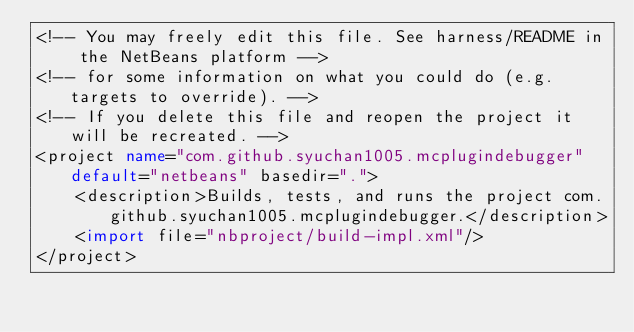Convert code to text. <code><loc_0><loc_0><loc_500><loc_500><_XML_><!-- You may freely edit this file. See harness/README in the NetBeans platform -->
<!-- for some information on what you could do (e.g. targets to override). -->
<!-- If you delete this file and reopen the project it will be recreated. -->
<project name="com.github.syuchan1005.mcplugindebugger" default="netbeans" basedir=".">
    <description>Builds, tests, and runs the project com.github.syuchan1005.mcplugindebugger.</description>
    <import file="nbproject/build-impl.xml"/>
</project>
</code> 